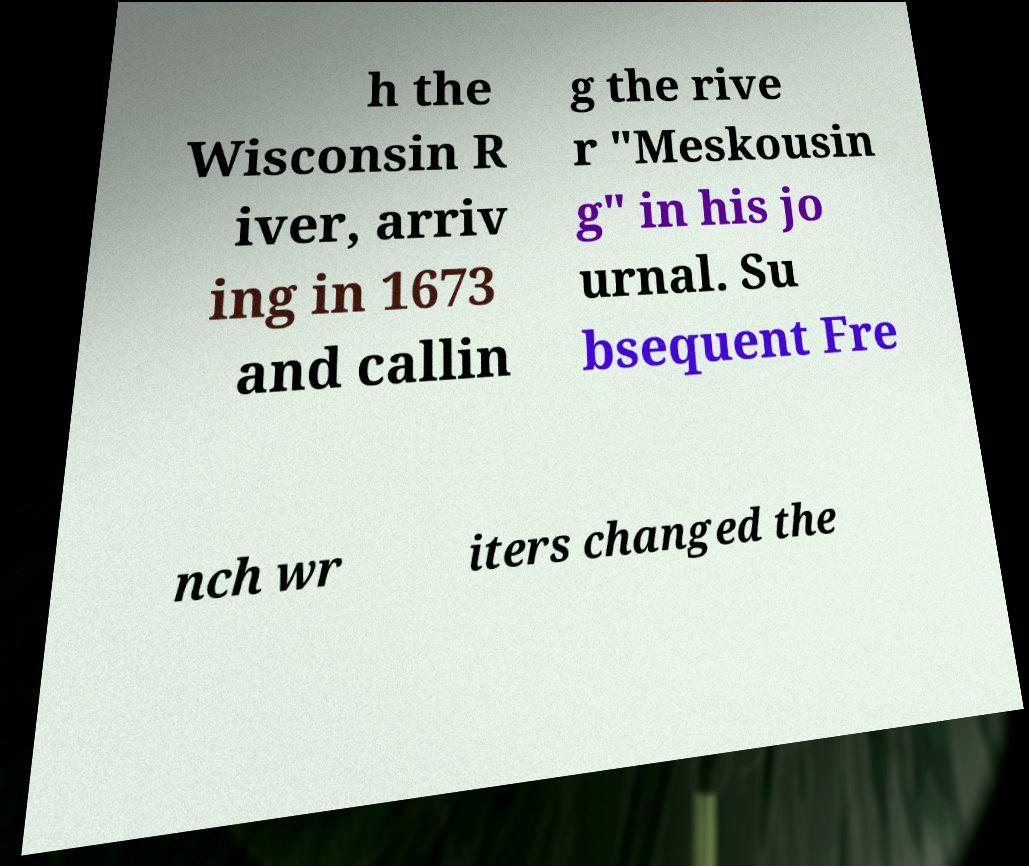Can you accurately transcribe the text from the provided image for me? h the Wisconsin R iver, arriv ing in 1673 and callin g the rive r "Meskousin g" in his jo urnal. Su bsequent Fre nch wr iters changed the 